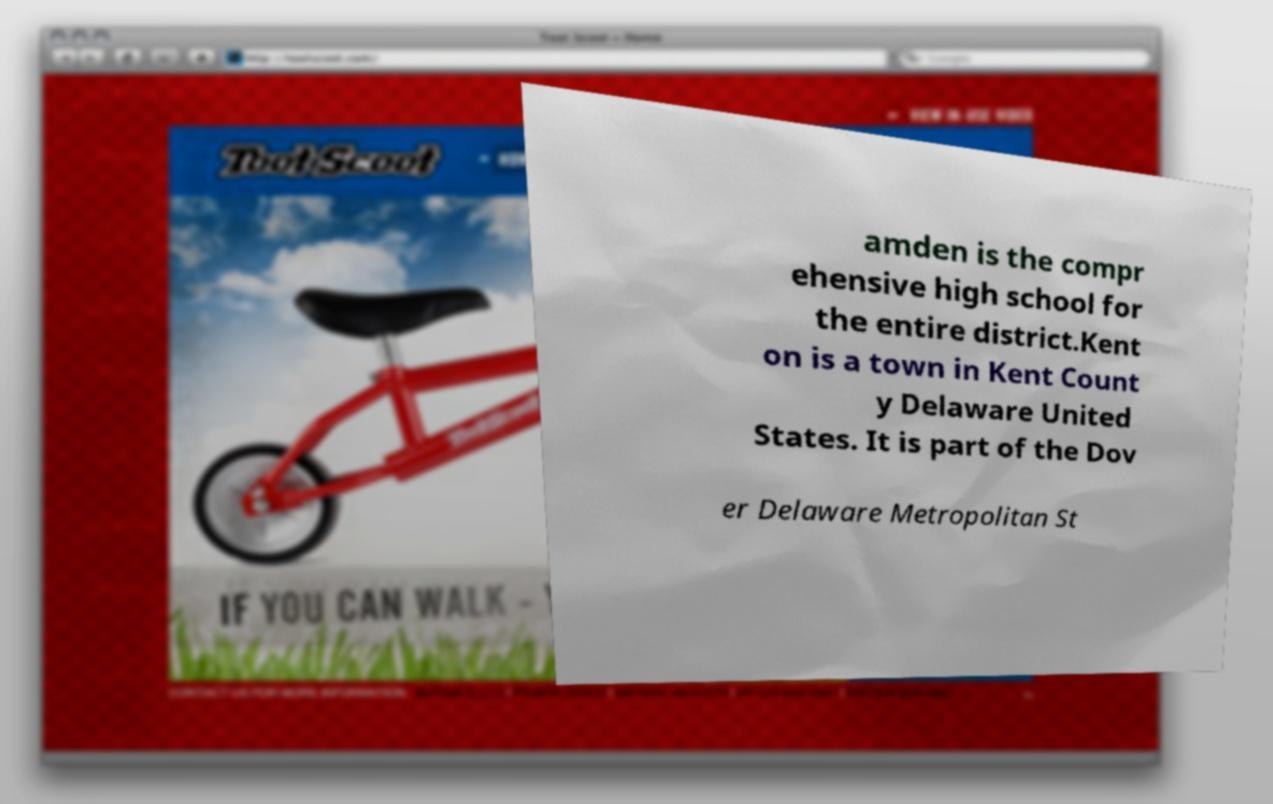For documentation purposes, I need the text within this image transcribed. Could you provide that? amden is the compr ehensive high school for the entire district.Kent on is a town in Kent Count y Delaware United States. It is part of the Dov er Delaware Metropolitan St 